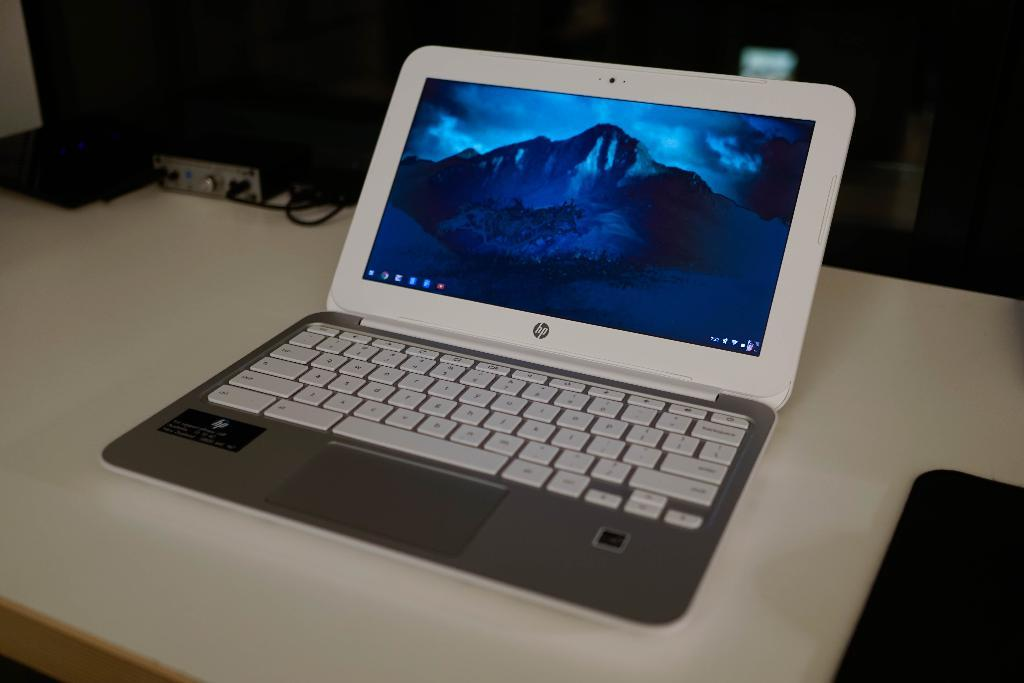<image>
Create a compact narrative representing the image presented. An HP brand laptop has a mountain showing on the screen. 